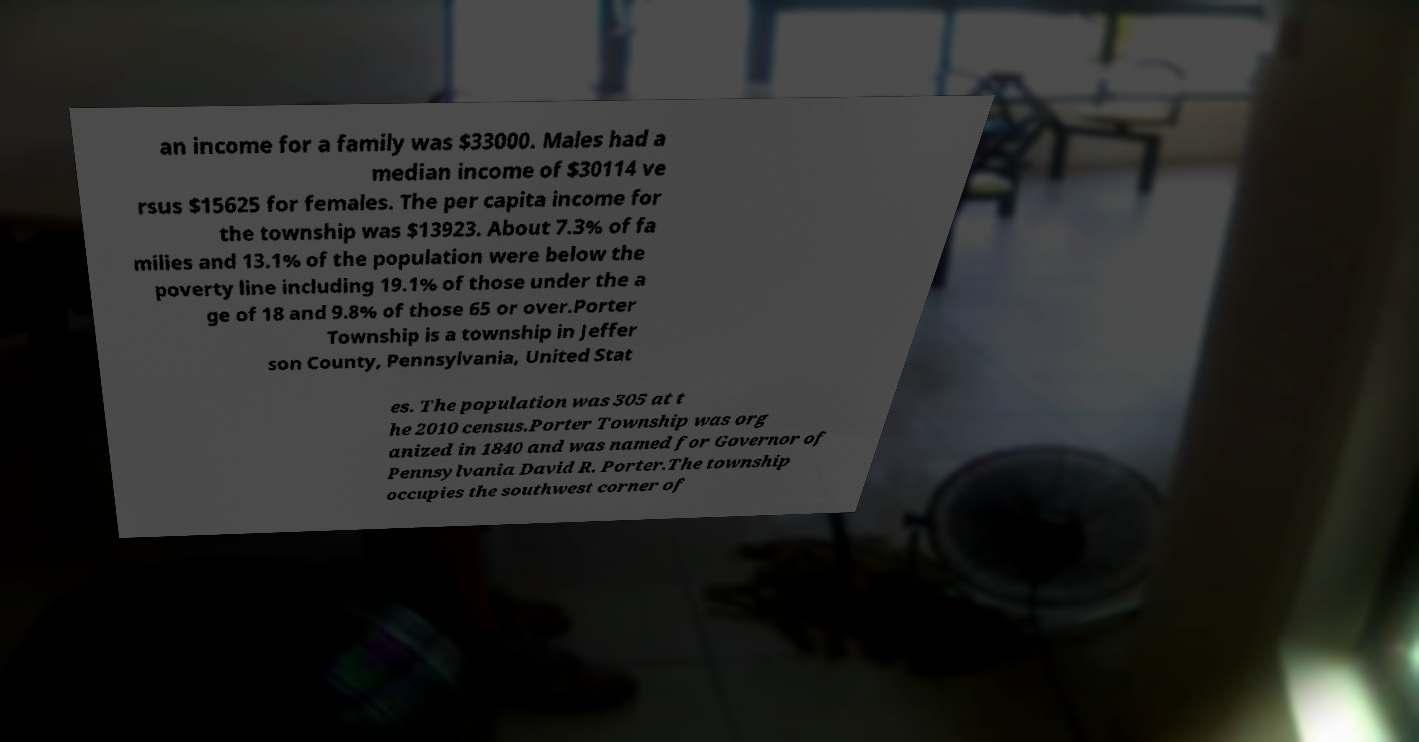What messages or text are displayed in this image? I need them in a readable, typed format. an income for a family was $33000. Males had a median income of $30114 ve rsus $15625 for females. The per capita income for the township was $13923. About 7.3% of fa milies and 13.1% of the population were below the poverty line including 19.1% of those under the a ge of 18 and 9.8% of those 65 or over.Porter Township is a township in Jeffer son County, Pennsylvania, United Stat es. The population was 305 at t he 2010 census.Porter Township was org anized in 1840 and was named for Governor of Pennsylvania David R. Porter.The township occupies the southwest corner of 